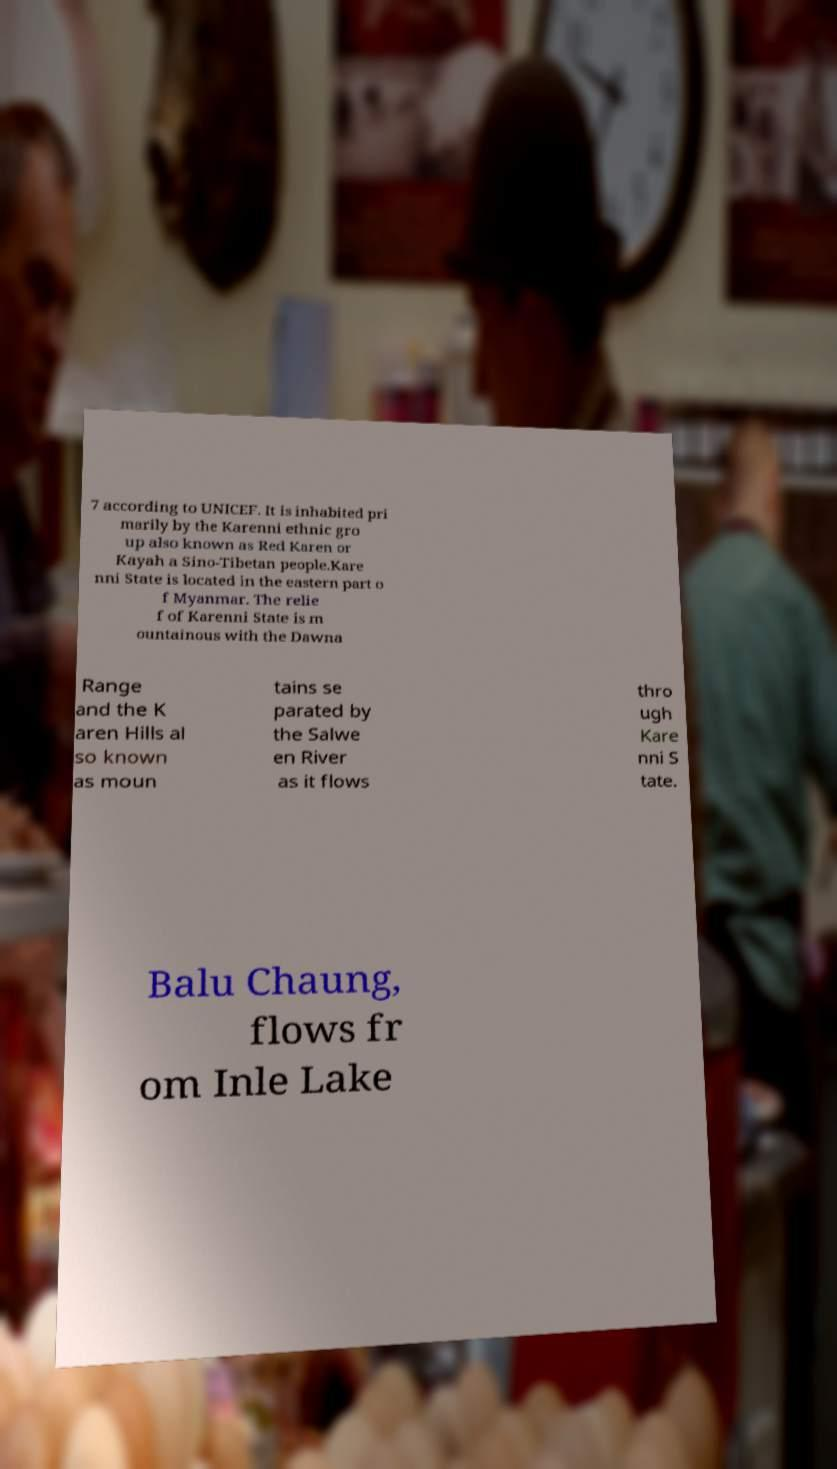Could you extract and type out the text from this image? 7 according to UNICEF. It is inhabited pri marily by the Karenni ethnic gro up also known as Red Karen or Kayah a Sino-Tibetan people.Kare nni State is located in the eastern part o f Myanmar. The relie f of Karenni State is m ountainous with the Dawna Range and the K aren Hills al so known as moun tains se parated by the Salwe en River as it flows thro ugh Kare nni S tate. Balu Chaung, flows fr om Inle Lake 